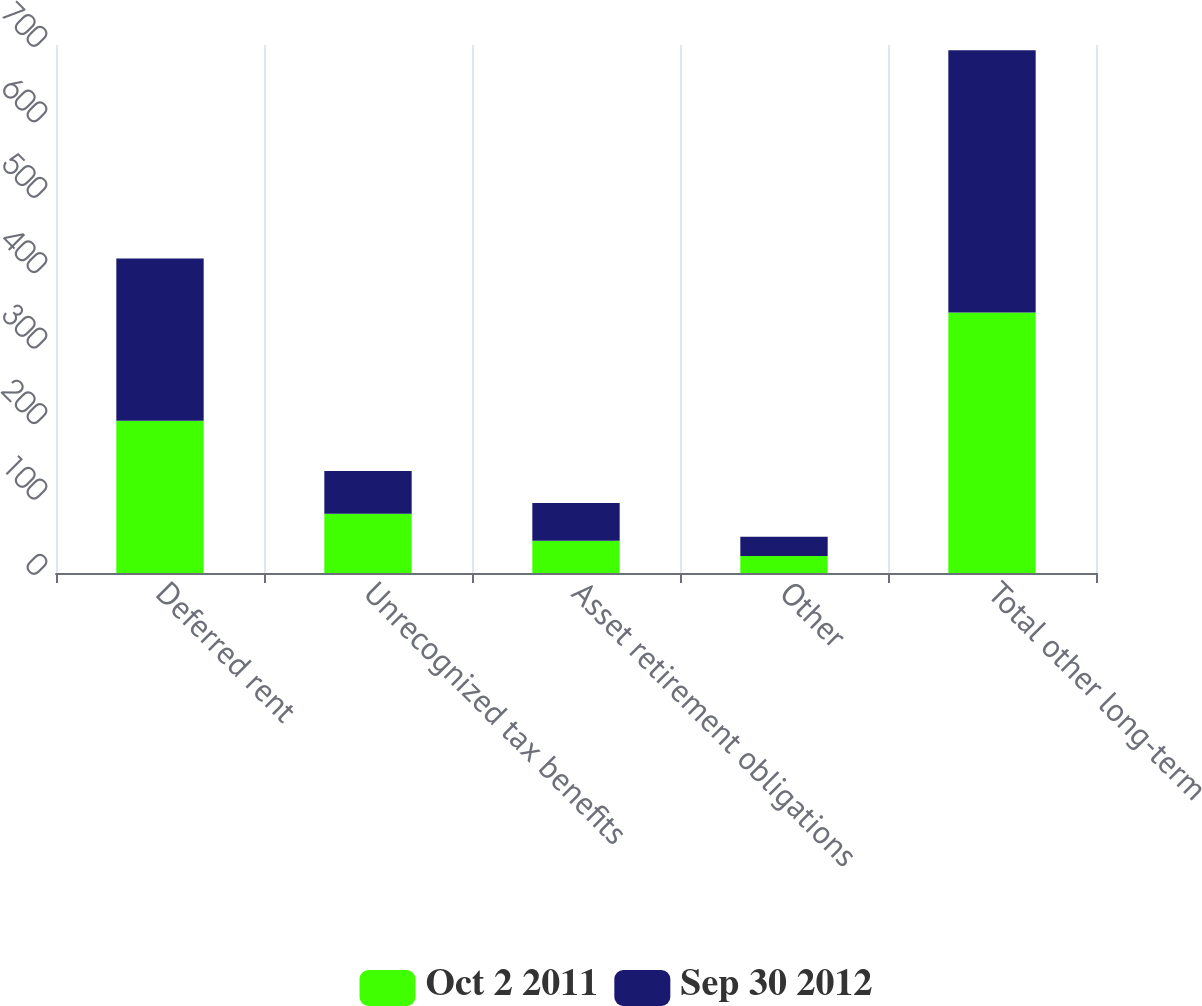Convert chart to OTSL. <chart><loc_0><loc_0><loc_500><loc_500><stacked_bar_chart><ecel><fcel>Deferred rent<fcel>Unrecognized tax benefits<fcel>Asset retirement obligations<fcel>Other<fcel>Total other long-term<nl><fcel>Oct 2 2011<fcel>201.9<fcel>78.4<fcel>42.6<fcel>22.4<fcel>345.3<nl><fcel>Sep 30 2012<fcel>215.2<fcel>56.7<fcel>50.1<fcel>25.8<fcel>347.8<nl></chart> 